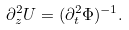Convert formula to latex. <formula><loc_0><loc_0><loc_500><loc_500>\partial _ { z } ^ { 2 } U = ( \partial _ { t } ^ { 2 } \Phi ) ^ { - 1 } .</formula> 